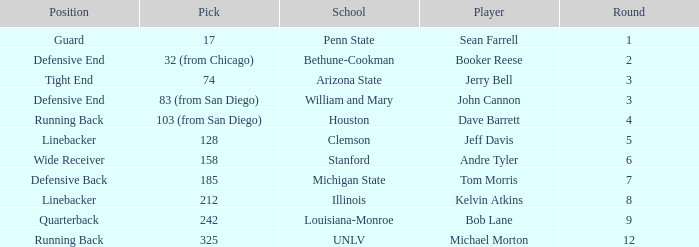Which school features a quarterback? Louisiana-Monroe. 